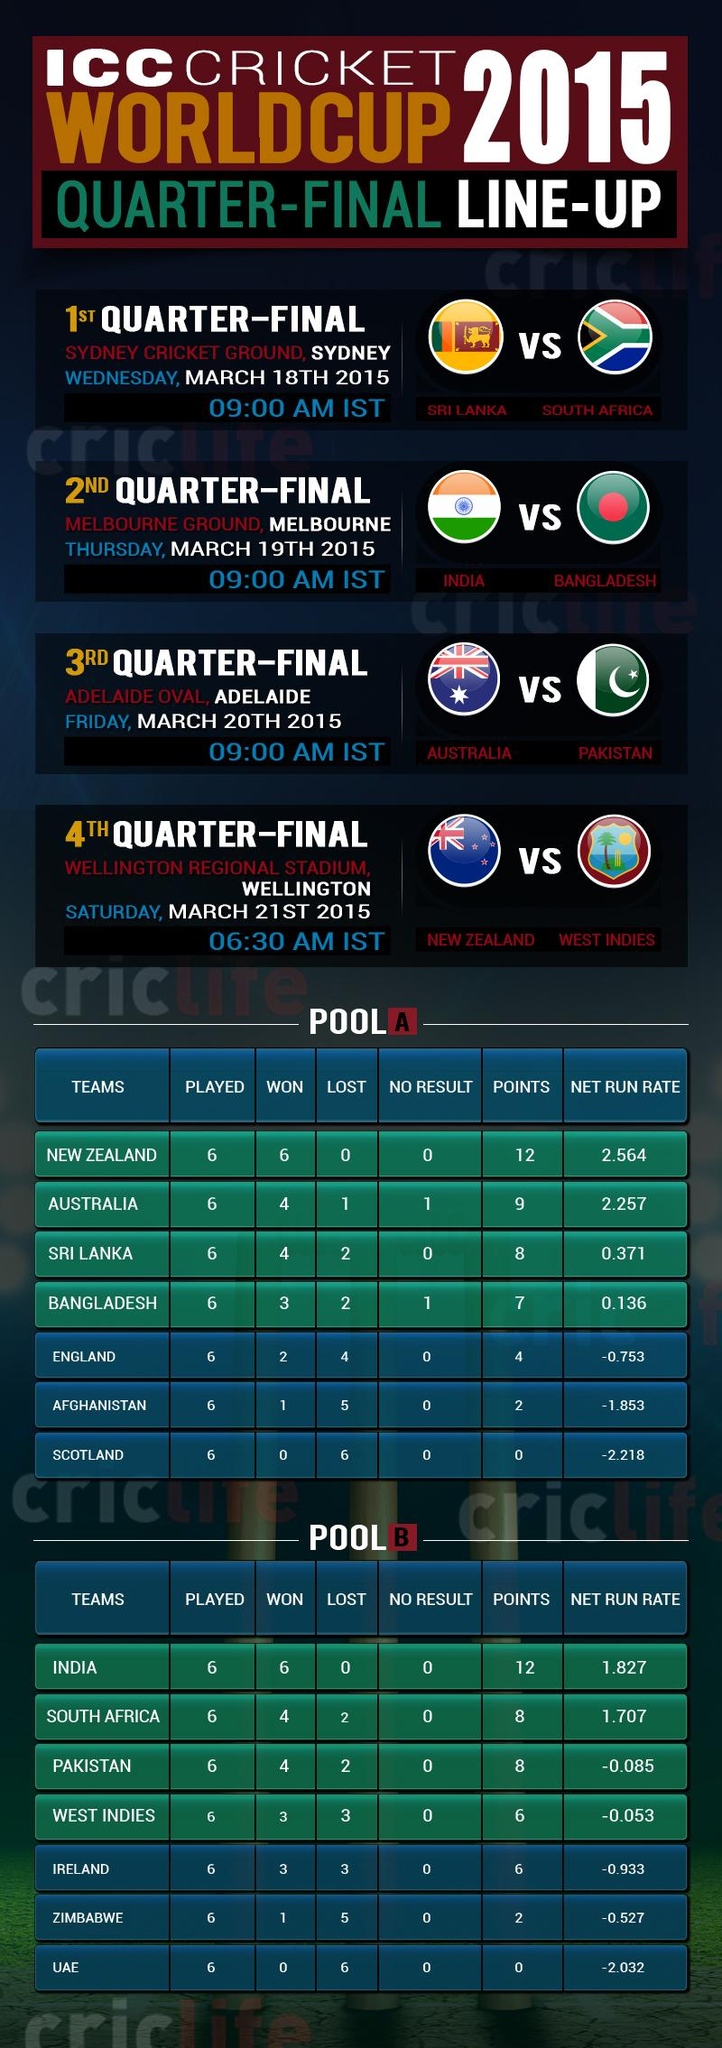List a handful of essential elements in this visual. Adelaide Oval will play host to the match between Australia and Pakistan, featuring two top-ranked cricket teams in the world. The first quarter final match is scheduled between Sri Lanka and South Africa. India, a team in Pool B, has 12 points. There are multiple teams in Pool B that have accumulated 8 points. South Africa is currently in second place in Pool B. 